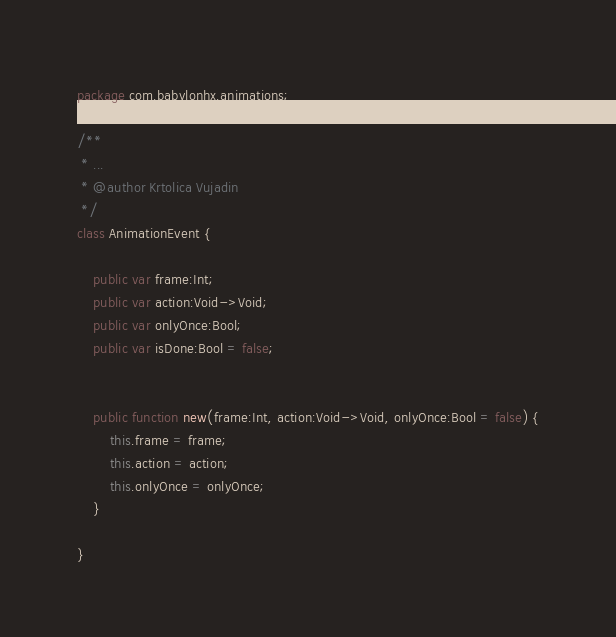Convert code to text. <code><loc_0><loc_0><loc_500><loc_500><_Haxe_>package com.babylonhx.animations;

/**
 * ...
 * @author Krtolica Vujadin
 */
class AnimationEvent {
	
	public var frame:Int;
	public var action:Void->Void;
	public var onlyOnce:Bool;
	public var isDone:Bool = false;
	

	public function new(frame:Int, action:Void->Void, onlyOnce:Bool = false) {
		this.frame = frame;
		this.action = action;
		this.onlyOnce = onlyOnce;
	}
	
}
</code> 